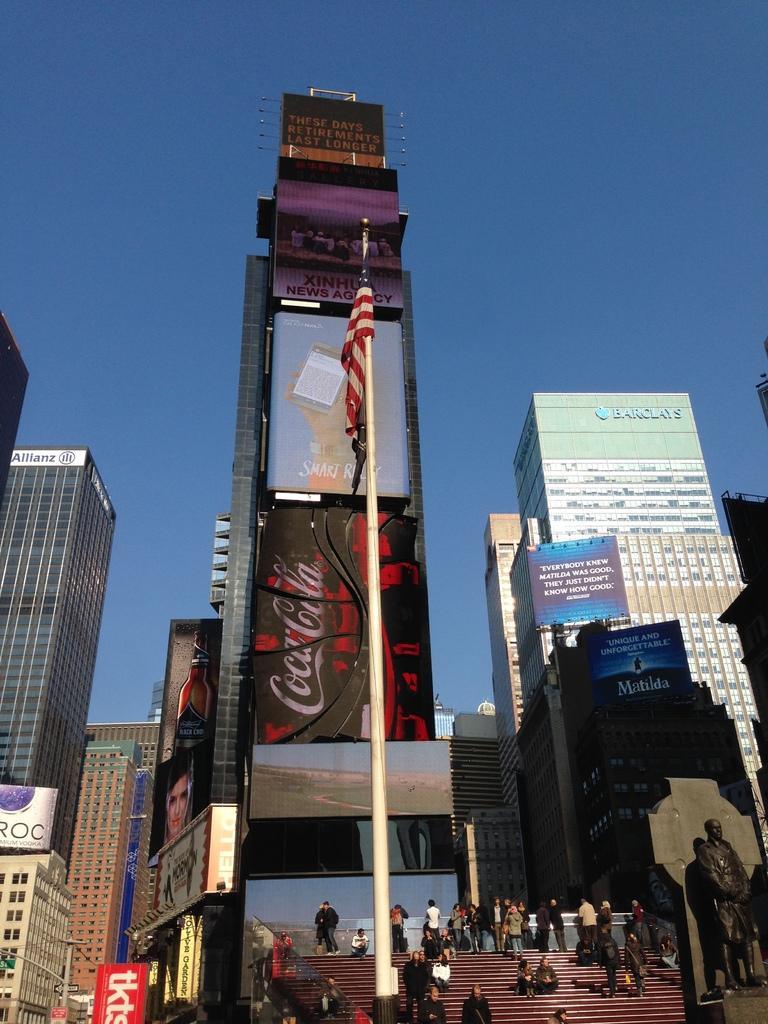Describe this image in one or two sentences. This picture shows few buildings and we see few people seated on the stairs and few are climbing up and few are getting down the stairs and we see advertisement hoardings and a flagpole and we see a blue sky. 